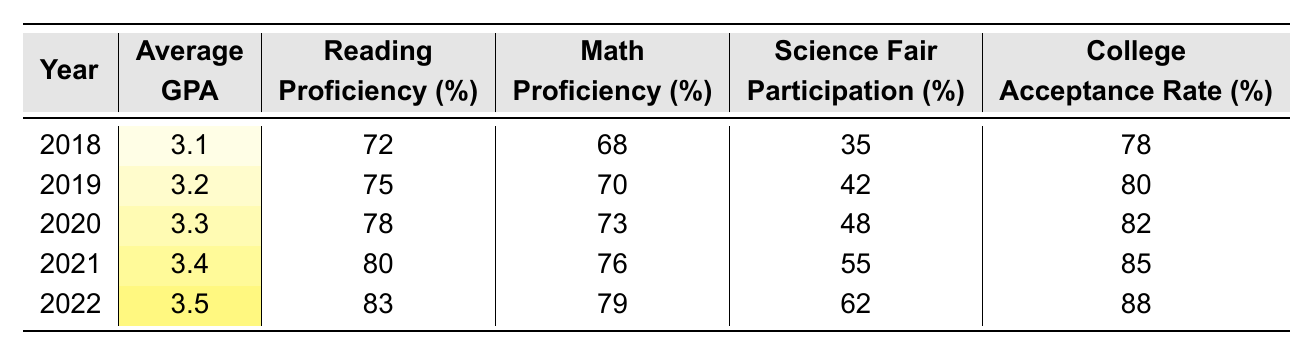What was the average GPA in 2020? In 2020, the table shows the Average GPA as 3.3.
Answer: 3.3 What percentage of students participated in the Science Fair in 2021? In 2021, the Science Fair Participation percentage is listed as 55%.
Answer: 55% Did the college acceptance rate increase from 2018 to 2022? Yes, comparing the values, it increased from 78% in 2018 to 88% in 2022.
Answer: Yes What is the difference in Reading Proficiency between 2019 and 2022? In 2019, Reading Proficiency is 75%, and in 2022, it's 83%. The difference is 83 - 75 = 8%.
Answer: 8% What was the average Math Proficiency over the 5-year period? The average Math Proficiency can be calculated by summing the percentages: (68 + 70 + 73 + 76 + 79) = 366 and dividing by 5, which gives us 366 / 5 = 73.2%.
Answer: 73.2% In which year did the highest Reading Proficiency occur? The highest Reading Proficiency of 83% occurred in 2022.
Answer: 2022 How much did the Average GPA increase from 2018 to 2022? The Average GPA in 2018 was 3.1 and in 2022 it was 3.5, so the increase is 3.5 - 3.1 = 0.4.
Answer: 0.4 Is the average Science Fair Participation higher or lower than the average Reading Proficiency over the five years? The averages are (35 + 42 + 48 + 55 + 62) / 5 = 48.4% for Science Fair Participation and (72 + 75 + 78 + 80 + 83) / 5 = 77.6% for Reading Proficiency; thus, Reading Proficiency is higher.
Answer: Higher What is the trend of College Acceptance Rate over the years? The College Acceptance Rate shows a consistent increase year over year, starting from 78% in 2018 to 88% in 2022.
Answer: Increased Was the average GPA in 2021 higher or lower compared to the average GPA in 2019? The average GPA in 2021 was 3.4, which is higher than the 3.2 in 2019.
Answer: Higher 